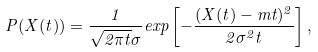Convert formula to latex. <formula><loc_0><loc_0><loc_500><loc_500>P ( X ( t ) ) = \frac { 1 } { \sqrt { 2 \pi t } \sigma } e x p \left [ - \frac { ( X ( t ) - m t ) ^ { 2 } } { 2 \sigma ^ { 2 } t } \right ] ,</formula> 